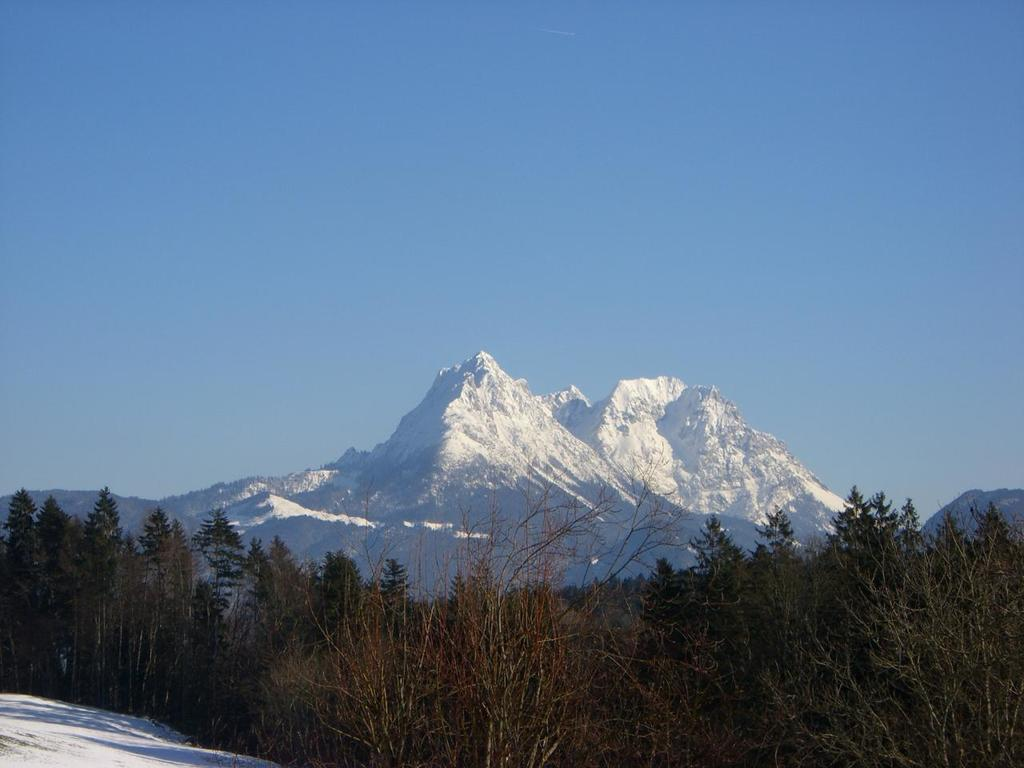What type of vegetation is present in the image? There are trees in the image. What geological features can be seen in the image? There are ice mountains in the image. What is visible at the top of the image? The sky is visible at the top of the image. Where is the pin located in the image? There is no pin present in the image. Can you see a stream in the image? There is no stream present in the image. 